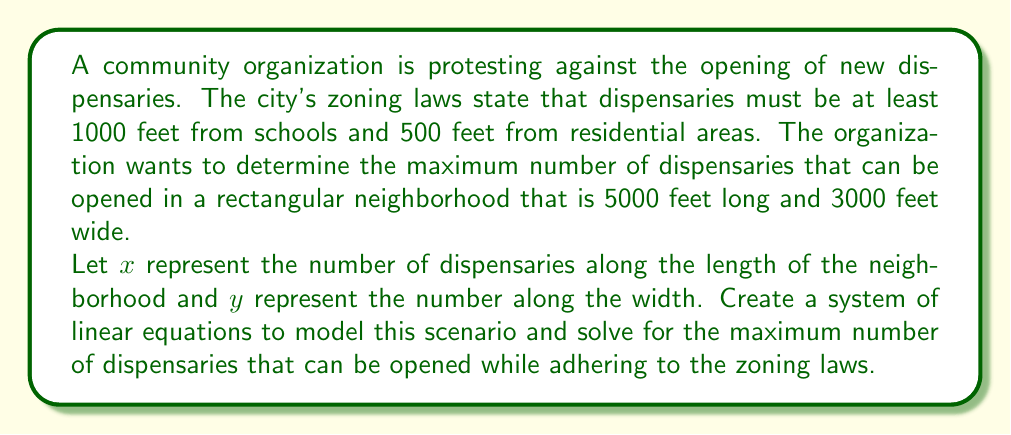Teach me how to tackle this problem. To solve this problem, we need to create a system of linear equations based on the given information:

1. Along the length (5000 feet):
   $$(x + 1) \cdot 1000 \leq 5000$$

2. Along the width (3000 feet):
   $$(y + 1) \cdot 500 \leq 3000$$

Let's solve these inequalities:

1. For the length:
   $$(x + 1) \cdot 1000 \leq 5000$$
   $$x + 1 \leq 5$$
   $$x \leq 4$$

   Since $x$ represents the number of dispensaries, it must be a non-negative integer. Therefore, the maximum value for $x$ is 4.

2. For the width:
   $$(y + 1) \cdot 500 \leq 3000$$
   $$y + 1 \leq 6$$
   $$y \leq 5$$

   Similarly, $y$ must be a non-negative integer, so the maximum value for $y$ is 5.

To find the total maximum number of dispensaries, we multiply the maximum values of $x$ and $y$:

$$\text{Maximum number of dispensaries} = x \cdot y = 4 \cdot 5 = 20$$

Therefore, the maximum number of dispensaries that can be opened in this neighborhood while adhering to the zoning laws is 20.
Answer: 20 dispensaries 